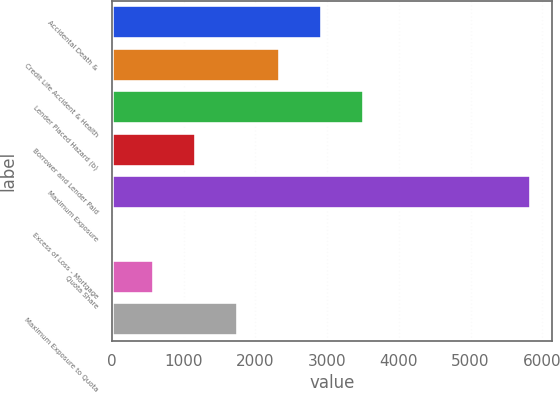<chart> <loc_0><loc_0><loc_500><loc_500><bar_chart><fcel>Accidental Death &<fcel>Credit Life Accident & Health<fcel>Lender Placed Hazard (b)<fcel>Borrower and Lender Paid<fcel>Maximum Exposure<fcel>Excess of Loss - Mortgage<fcel>Quota Share<fcel>Maximum Exposure to Quota<nl><fcel>2924.5<fcel>2340.2<fcel>3508.8<fcel>1171.6<fcel>5846<fcel>3<fcel>587.3<fcel>1755.9<nl></chart> 